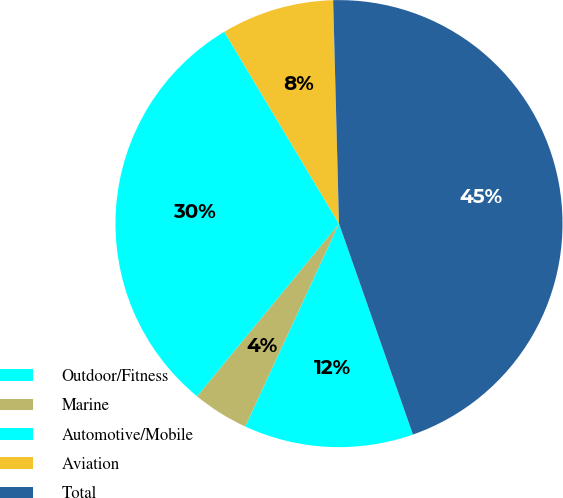Convert chart to OTSL. <chart><loc_0><loc_0><loc_500><loc_500><pie_chart><fcel>Outdoor/Fitness<fcel>Marine<fcel>Automotive/Mobile<fcel>Aviation<fcel>Total<nl><fcel>12.26%<fcel>4.06%<fcel>30.48%<fcel>8.16%<fcel>45.06%<nl></chart> 